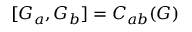<formula> <loc_0><loc_0><loc_500><loc_500>[ G _ { a } , G _ { b } ] = C _ { a b } ( G )</formula> 